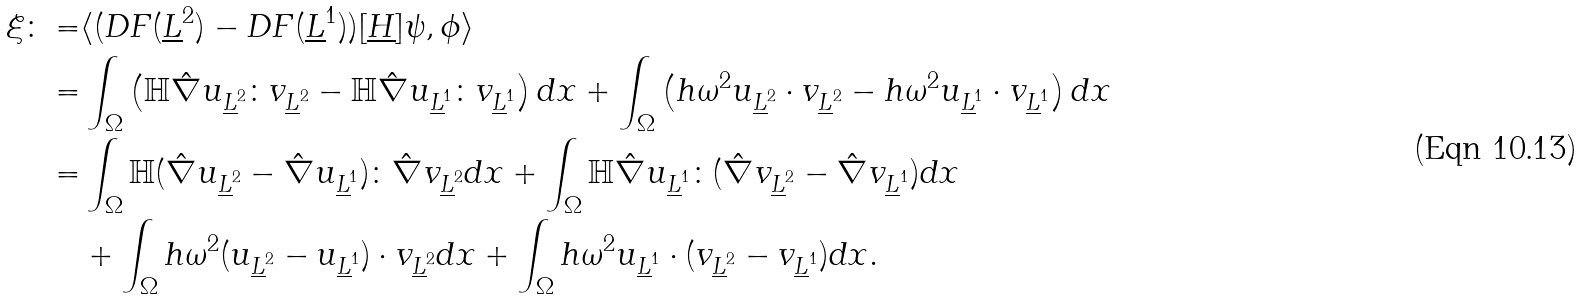<formula> <loc_0><loc_0><loc_500><loc_500>\xi \colon = & \langle ( D F ( \underline { L } ^ { 2 } ) - D F ( \underline { L } ^ { 1 } ) ) [ \underline { H } ] \psi , \phi \rangle \\ = & \int _ { \Omega } \left ( \mathbb { H } \hat { \nabla } u _ { \underline { L } ^ { 2 } } \colon v _ { \underline { L } ^ { 2 } } - \mathbb { H } \hat { \nabla } u _ { \underline { L } ^ { 1 } } \colon v _ { \underline { L } ^ { 1 } } \right ) d x + \int _ { \Omega } \left ( h \omega ^ { 2 } u _ { \underline { L } ^ { 2 } } \cdot v _ { \underline { L } ^ { 2 } } - h \omega ^ { 2 } u _ { \underline { L } ^ { 1 } } \cdot v _ { \underline { L } ^ { 1 } } \right ) d x \\ = & \int _ { \Omega } \mathbb { H } ( \hat { \nabla } u _ { \underline { L } ^ { 2 } } - \hat { \nabla } u _ { \underline { L } ^ { 1 } } ) \colon \hat { \nabla } v _ { \underline { L } ^ { 2 } } d x + \int _ { \Omega } \mathbb { H } \hat { \nabla } u _ { \underline { L } ^ { 1 } } \colon ( \hat { \nabla } v _ { \underline { L } ^ { 2 } } - \hat { \nabla } v _ { \underline { L } ^ { 1 } } ) d x \\ & + \int _ { \Omega } h \omega ^ { 2 } ( u _ { \underline { L } ^ { 2 } } - u _ { \underline { L } ^ { 1 } } ) \cdot v _ { \underline { L } ^ { 2 } } d x + \int _ { \Omega } h \omega ^ { 2 } u _ { \underline { L } ^ { 1 } } \cdot ( v _ { \underline { L } ^ { 2 } } - v _ { \underline { L } ^ { 1 } } ) d x .</formula> 